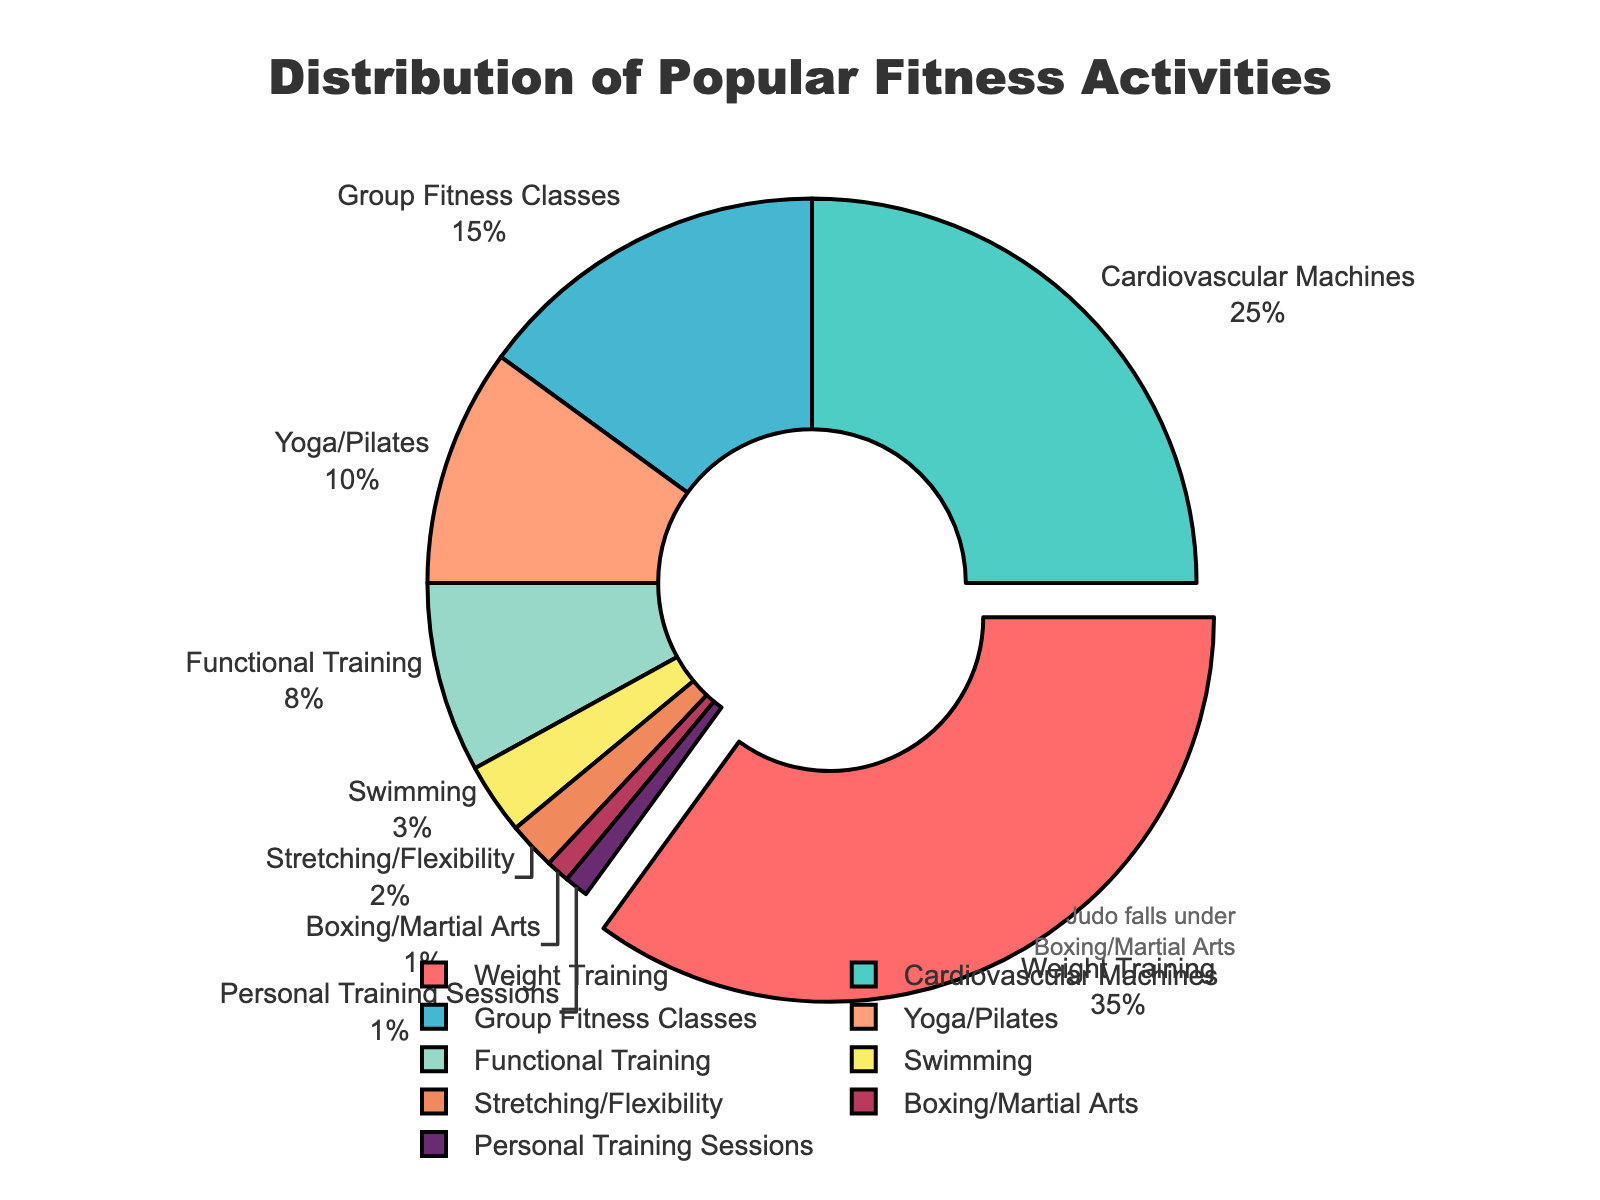What percentage of gym-goers participate in Weight Training? The figure shows that Weight Training has a section with the percentage labeled as 35%. Therefore, 35% of gym-goers participate in Weight Training.
Answer: 35% Which activity has the smallest percentage? By observing the figure, the smallest section is labeled Boxing/Martial Arts, which has 1%. Therefore, Boxing/Martial Arts has the smallest percentage.
Answer: Boxing/Martial Arts How much greater is the participation in Cardiovascular Machines compared to Yoga/Pilates? Referring to the figure, Cardiovascular Machines has 25% while Yoga/Pilates has 10%. The difference is 25% - 10%, which is 15%.
Answer: 15% Which activities have a participation rate below 5%? Looking at the figure, we can identify activities with percentages less than 5%: Swimming (3%), Stretching/Flexibility (2%), and Boxing/Martial Arts (1%), and Personal Training Sessions (1%).
Answer: Swimming, Stretching/Flexibility, Boxing/Martial Arts, Personal Training Sessions What is the combined percentage of gym-goers who participate in Functional Training and Weight Training? According to the figure, Functional Training has 8% and Weight Training has 35%. Adding these together, 8% + 35% equals 43%.
Answer: 43% Which has a higher participation: Group Fitness Classes or Yoga/Pilates? The figure shows that Group Fitness Classes have 15% participation, whereas Yoga/Pilates have 10%. Therefore, Group Fitness Classes have a higher participation than Yoga/Pilates.
Answer: Group Fitness Classes How many times greater is the Weight Training participation compared to Swimming? The figure indicates that Weight Training has 35% and Swimming has 3%. To find how many times greater, divide 35 by 3, which gives approximately 11.67 times.
Answer: 11.67 times What is the visual attribute that makes Weight Training stand out in the pie chart? In the figure, the section for Weight Training is "pulled out" slightly from the center compared to other sections, making it more prominent visually.
Answer: Pulled out If we group all activities other than Weight Training and Cardiovascular Machines, what percentage do they together form? Activities other than Weight Training (35%) and Cardiovascular Machines (25%) sum up to 100% - (35% + 25%) which equals 40%.
Answer: 40% What annotation is present in the figure, and what does it refer to? The figure includes an annotation stating "Judo falls under Boxing/Martial Arts" which indicates that Judo is categorized along with Boxing/Martial Arts activities, which have a 1% participation rate.
Answer: Judo falls under Boxing/Martial Arts 